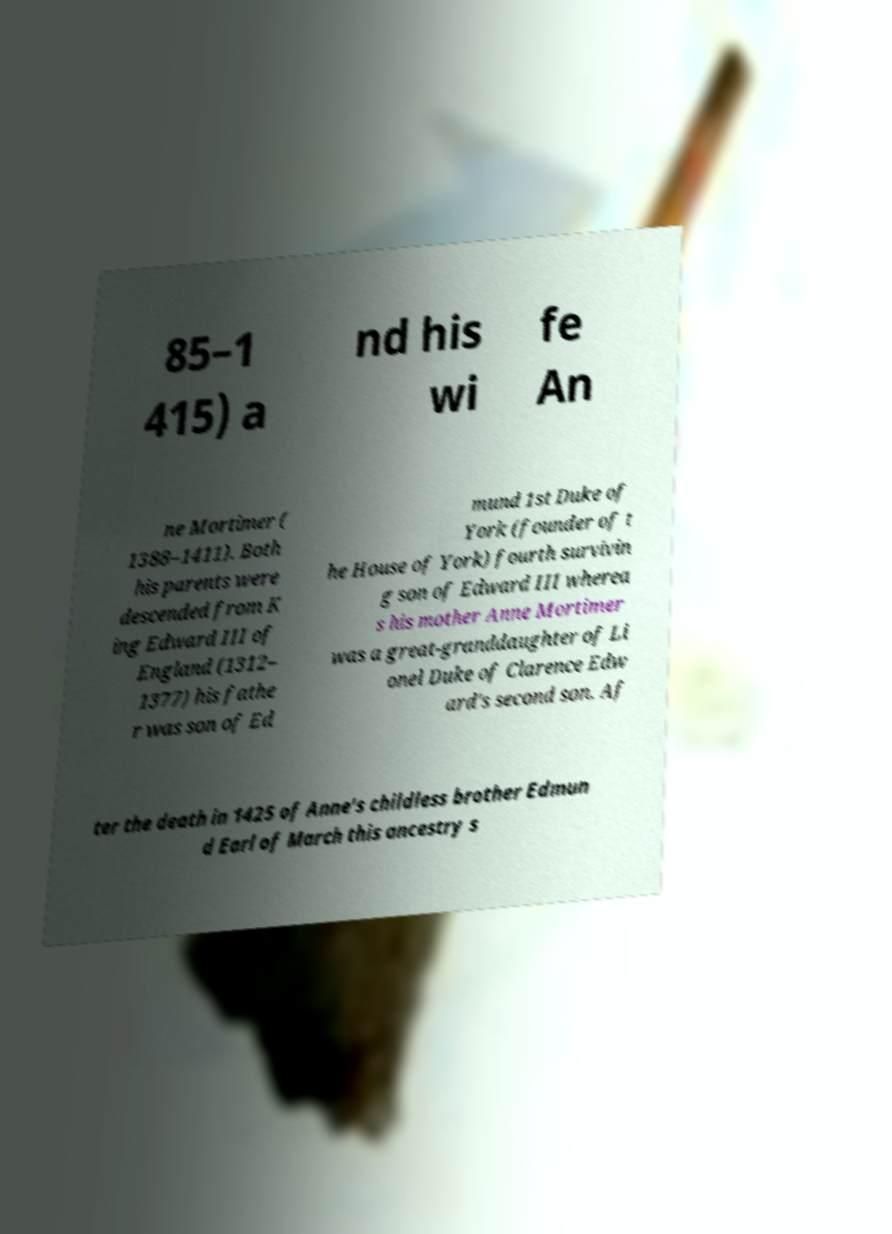Please identify and transcribe the text found in this image. 85–1 415) a nd his wi fe An ne Mortimer ( 1388–1411). Both his parents were descended from K ing Edward III of England (1312– 1377) his fathe r was son of Ed mund 1st Duke of York (founder of t he House of York) fourth survivin g son of Edward III wherea s his mother Anne Mortimer was a great-granddaughter of Li onel Duke of Clarence Edw ard's second son. Af ter the death in 1425 of Anne's childless brother Edmun d Earl of March this ancestry s 